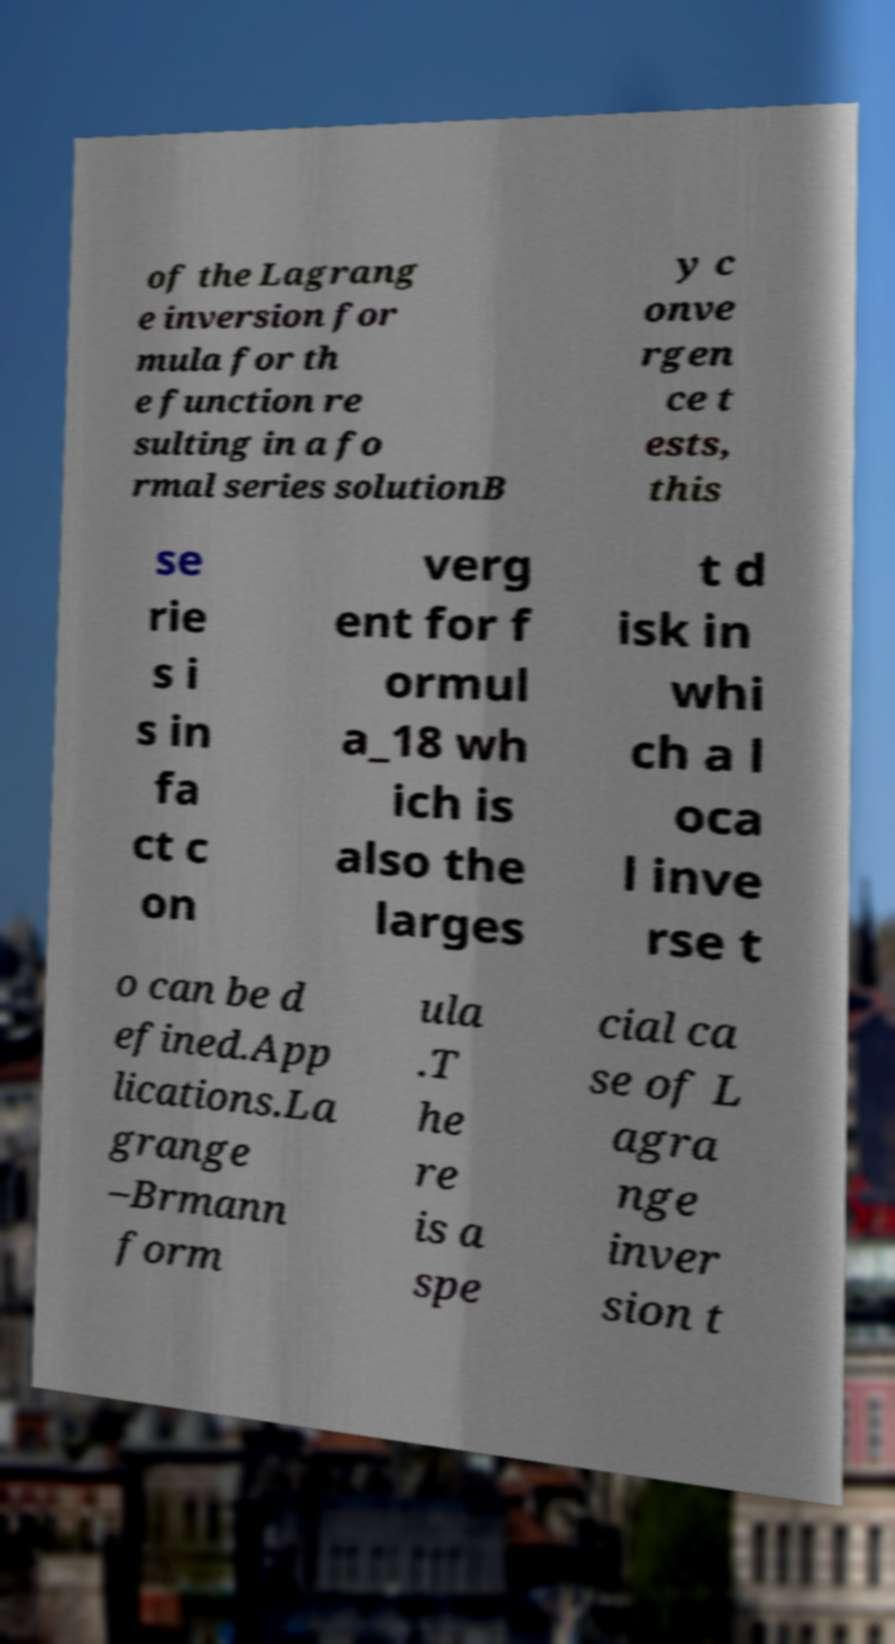Could you extract and type out the text from this image? of the Lagrang e inversion for mula for th e function re sulting in a fo rmal series solutionB y c onve rgen ce t ests, this se rie s i s in fa ct c on verg ent for f ormul a_18 wh ich is also the larges t d isk in whi ch a l oca l inve rse t o can be d efined.App lications.La grange –Brmann form ula .T he re is a spe cial ca se of L agra nge inver sion t 